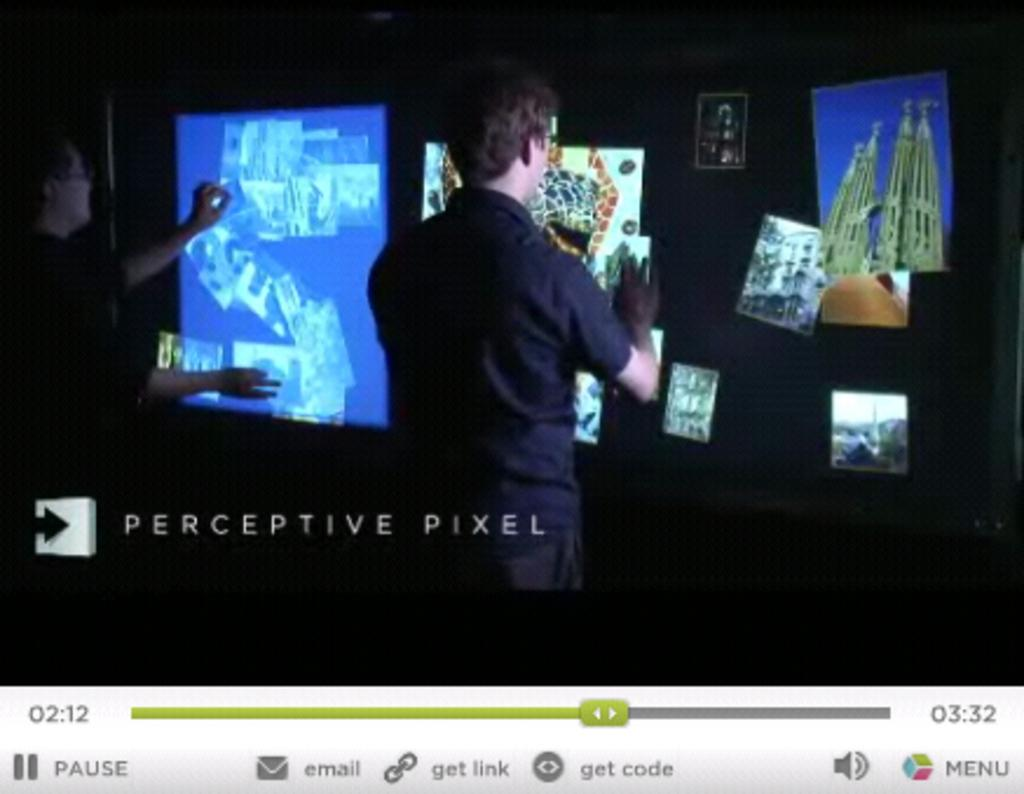<image>
Offer a succinct explanation of the picture presented. Perceptive Pixel is displayed in the left lower corner of the screen. 